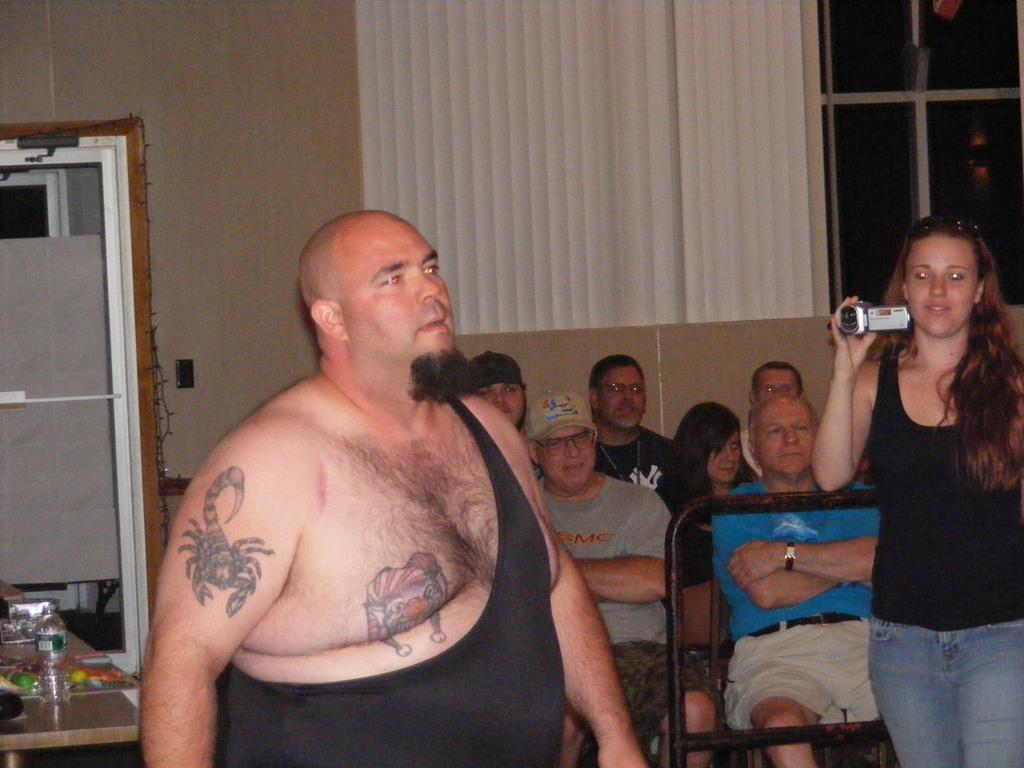In one or two sentences, can you explain what this image depicts? In this image we can see a man on the left side. In the background there are few persons sitting on the chairs and a woman is holding a camera in her hand. On the left side there is a bottle and objects on a table, windows, wall, window blinds and wall. 